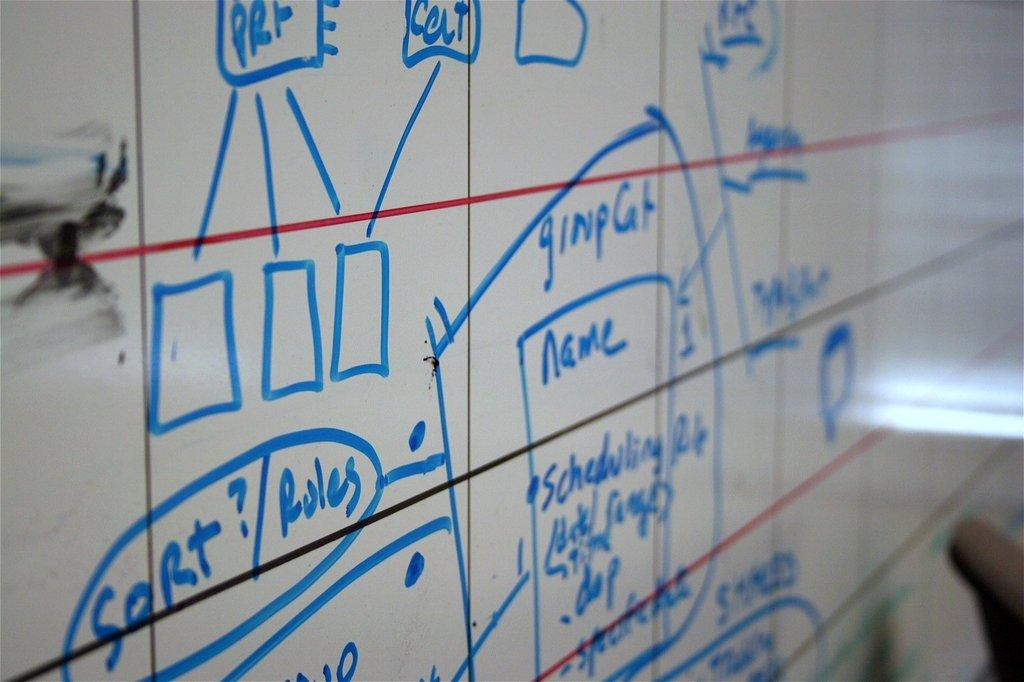<image>
Present a compact description of the photo's key features. A flow chart is shown on a dry erase board with headings such as Sort and Name. 